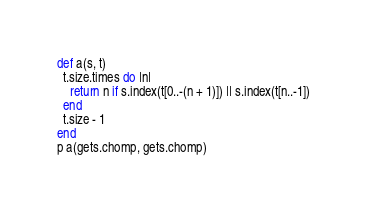<code> <loc_0><loc_0><loc_500><loc_500><_Ruby_>def a(s, t)
  t.size.times do |n|
    return n if s.index(t[0..-(n + 1)]) || s.index(t[n..-1])
  end
  t.size - 1
end
p a(gets.chomp, gets.chomp)</code> 